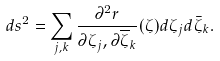<formula> <loc_0><loc_0><loc_500><loc_500>d s ^ { 2 } = \sum _ { j , k } \frac { \partial ^ { 2 } r } { \partial \zeta _ { j } , \partial \overline { \zeta } _ { k } } ( \zeta ) d \zeta _ { j } d \bar { \zeta } _ { k } .</formula> 